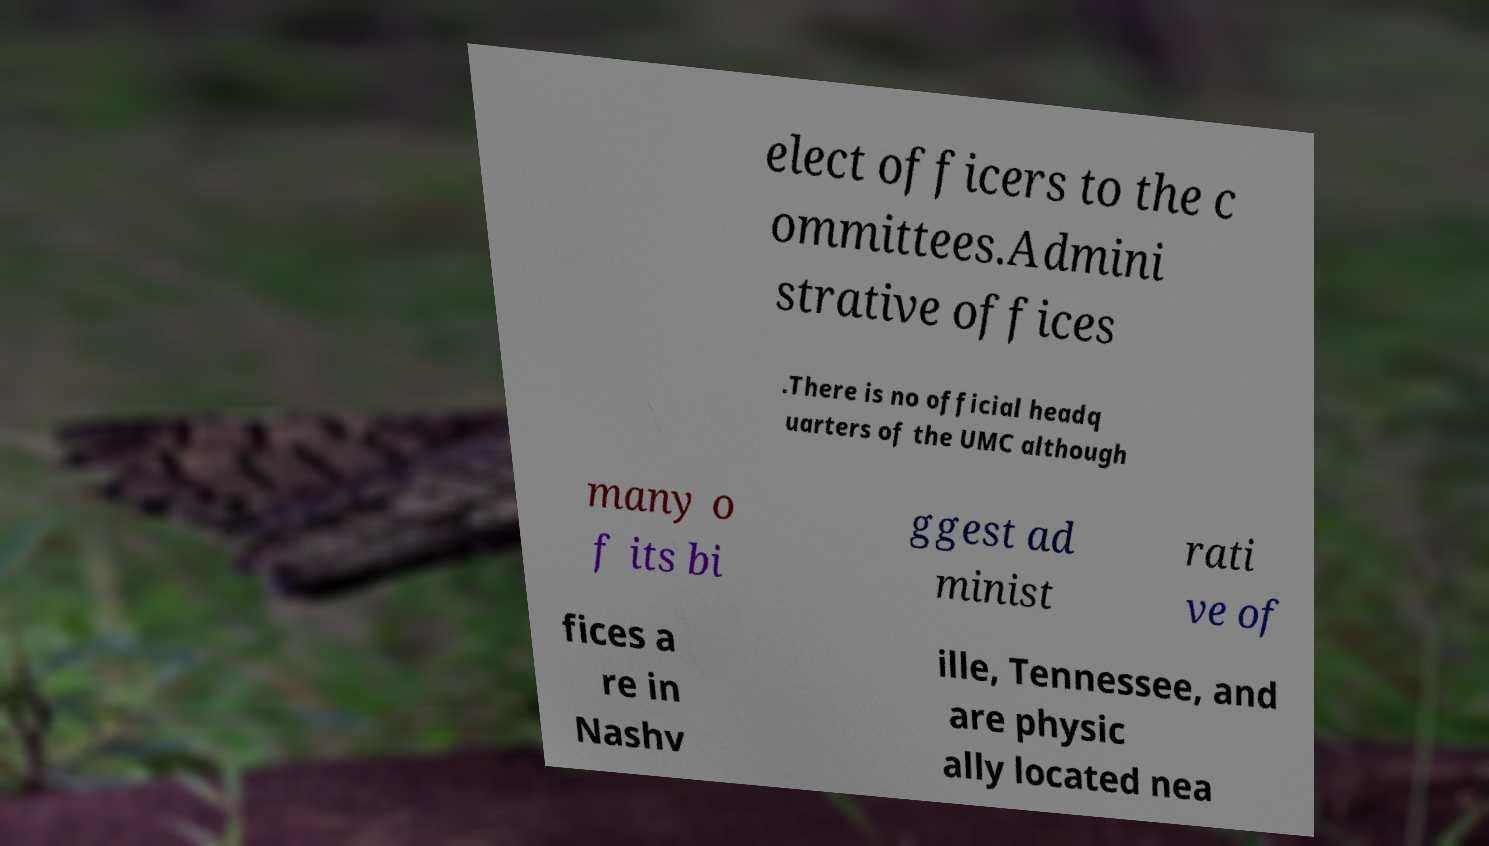Could you extract and type out the text from this image? elect officers to the c ommittees.Admini strative offices .There is no official headq uarters of the UMC although many o f its bi ggest ad minist rati ve of fices a re in Nashv ille, Tennessee, and are physic ally located nea 